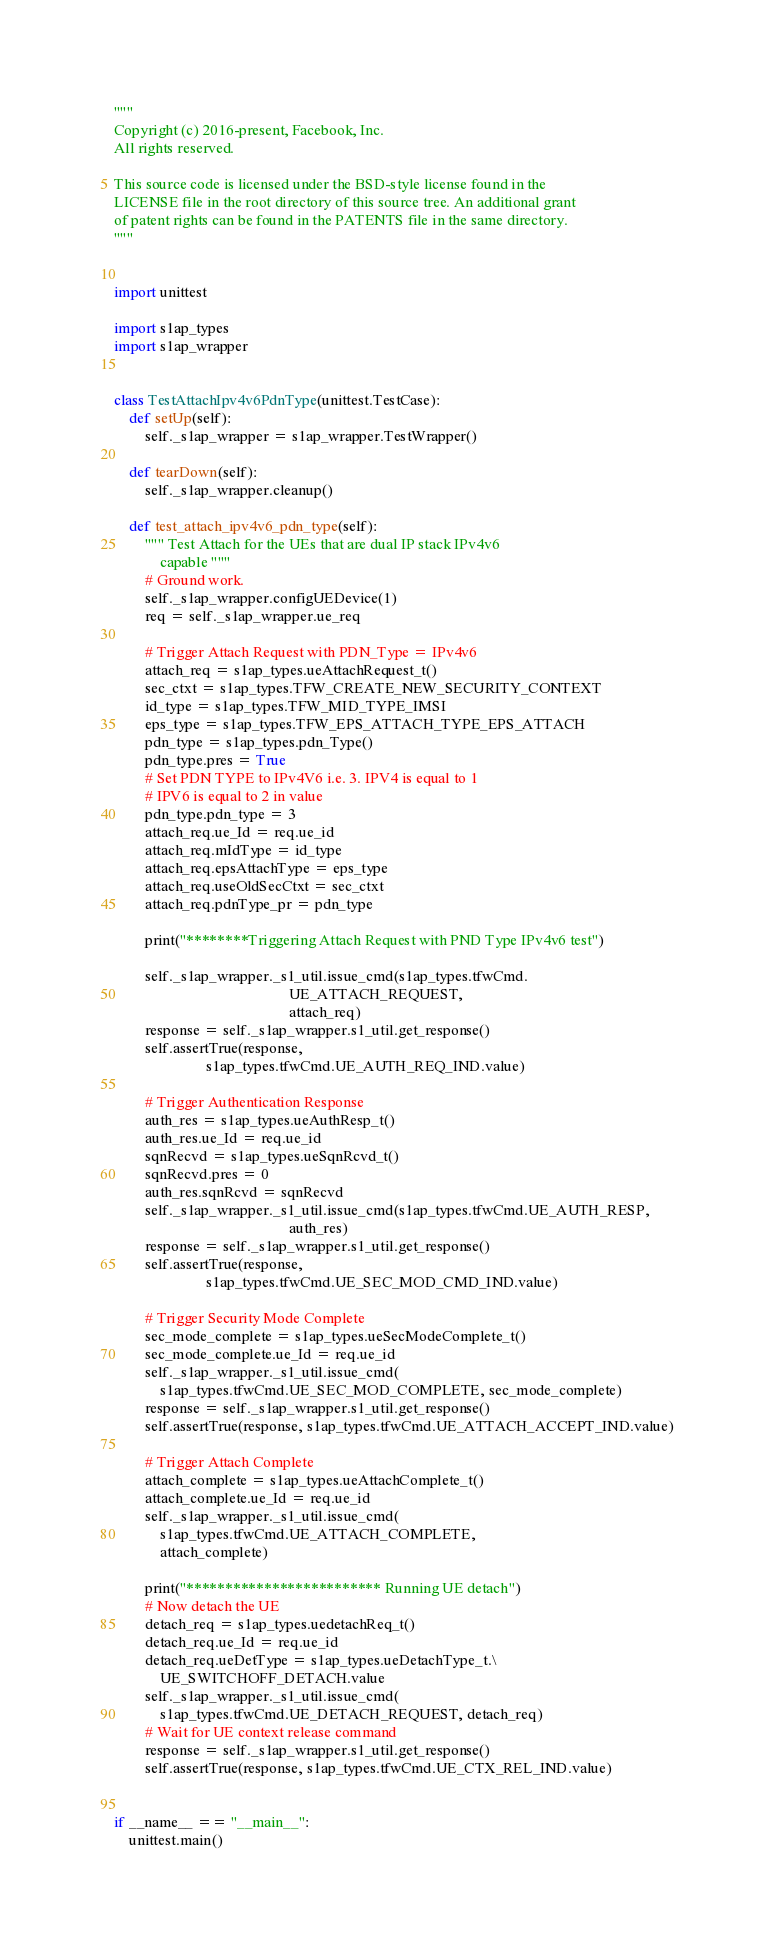Convert code to text. <code><loc_0><loc_0><loc_500><loc_500><_Python_>"""
Copyright (c) 2016-present, Facebook, Inc.
All rights reserved.

This source code is licensed under the BSD-style license found in the
LICENSE file in the root directory of this source tree. An additional grant
of patent rights can be found in the PATENTS file in the same directory.
"""


import unittest

import s1ap_types
import s1ap_wrapper


class TestAttachIpv4v6PdnType(unittest.TestCase):
    def setUp(self):
        self._s1ap_wrapper = s1ap_wrapper.TestWrapper()

    def tearDown(self):
        self._s1ap_wrapper.cleanup()

    def test_attach_ipv4v6_pdn_type(self):
        """ Test Attach for the UEs that are dual IP stack IPv4v6
            capable """
        # Ground work.
        self._s1ap_wrapper.configUEDevice(1)
        req = self._s1ap_wrapper.ue_req

        # Trigger Attach Request with PDN_Type = IPv4v6
        attach_req = s1ap_types.ueAttachRequest_t()
        sec_ctxt = s1ap_types.TFW_CREATE_NEW_SECURITY_CONTEXT
        id_type = s1ap_types.TFW_MID_TYPE_IMSI
        eps_type = s1ap_types.TFW_EPS_ATTACH_TYPE_EPS_ATTACH
        pdn_type = s1ap_types.pdn_Type()
        pdn_type.pres = True
        # Set PDN TYPE to IPv4V6 i.e. 3. IPV4 is equal to 1
        # IPV6 is equal to 2 in value
        pdn_type.pdn_type = 3
        attach_req.ue_Id = req.ue_id
        attach_req.mIdType = id_type
        attach_req.epsAttachType = eps_type
        attach_req.useOldSecCtxt = sec_ctxt
        attach_req.pdnType_pr = pdn_type

        print("********Triggering Attach Request with PND Type IPv4v6 test")

        self._s1ap_wrapper._s1_util.issue_cmd(s1ap_types.tfwCmd.
                                              UE_ATTACH_REQUEST,
                                              attach_req)
        response = self._s1ap_wrapper.s1_util.get_response()
        self.assertTrue(response,
                        s1ap_types.tfwCmd.UE_AUTH_REQ_IND.value)

        # Trigger Authentication Response
        auth_res = s1ap_types.ueAuthResp_t()
        auth_res.ue_Id = req.ue_id
        sqnRecvd = s1ap_types.ueSqnRcvd_t()
        sqnRecvd.pres = 0
        auth_res.sqnRcvd = sqnRecvd
        self._s1ap_wrapper._s1_util.issue_cmd(s1ap_types.tfwCmd.UE_AUTH_RESP,
                                              auth_res)
        response = self._s1ap_wrapper.s1_util.get_response()
        self.assertTrue(response,
                        s1ap_types.tfwCmd.UE_SEC_MOD_CMD_IND.value)

        # Trigger Security Mode Complete
        sec_mode_complete = s1ap_types.ueSecModeComplete_t()
        sec_mode_complete.ue_Id = req.ue_id
        self._s1ap_wrapper._s1_util.issue_cmd(
            s1ap_types.tfwCmd.UE_SEC_MOD_COMPLETE, sec_mode_complete)
        response = self._s1ap_wrapper.s1_util.get_response()
        self.assertTrue(response, s1ap_types.tfwCmd.UE_ATTACH_ACCEPT_IND.value)

        # Trigger Attach Complete
        attach_complete = s1ap_types.ueAttachComplete_t()
        attach_complete.ue_Id = req.ue_id
        self._s1ap_wrapper._s1_util.issue_cmd(
            s1ap_types.tfwCmd.UE_ATTACH_COMPLETE,
            attach_complete)

        print("************************* Running UE detach")
        # Now detach the UE
        detach_req = s1ap_types.uedetachReq_t()
        detach_req.ue_Id = req.ue_id
        detach_req.ueDetType = s1ap_types.ueDetachType_t.\
            UE_SWITCHOFF_DETACH.value
        self._s1ap_wrapper._s1_util.issue_cmd(
            s1ap_types.tfwCmd.UE_DETACH_REQUEST, detach_req)
        # Wait for UE context release command
        response = self._s1ap_wrapper.s1_util.get_response()
        self.assertTrue(response, s1ap_types.tfwCmd.UE_CTX_REL_IND.value)


if __name__ == "__main__":
    unittest.main()
</code> 